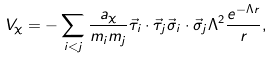Convert formula to latex. <formula><loc_0><loc_0><loc_500><loc_500>V _ { \chi } = - \sum _ { i < j } \frac { a _ { \chi } } { m _ { i } m _ { j } } \vec { \tau } _ { i } \cdot \vec { \tau } _ { j } \vec { \sigma } _ { i } \cdot \vec { \sigma } _ { j } \Lambda ^ { 2 } \frac { e ^ { - \Lambda r } } { r } ,</formula> 